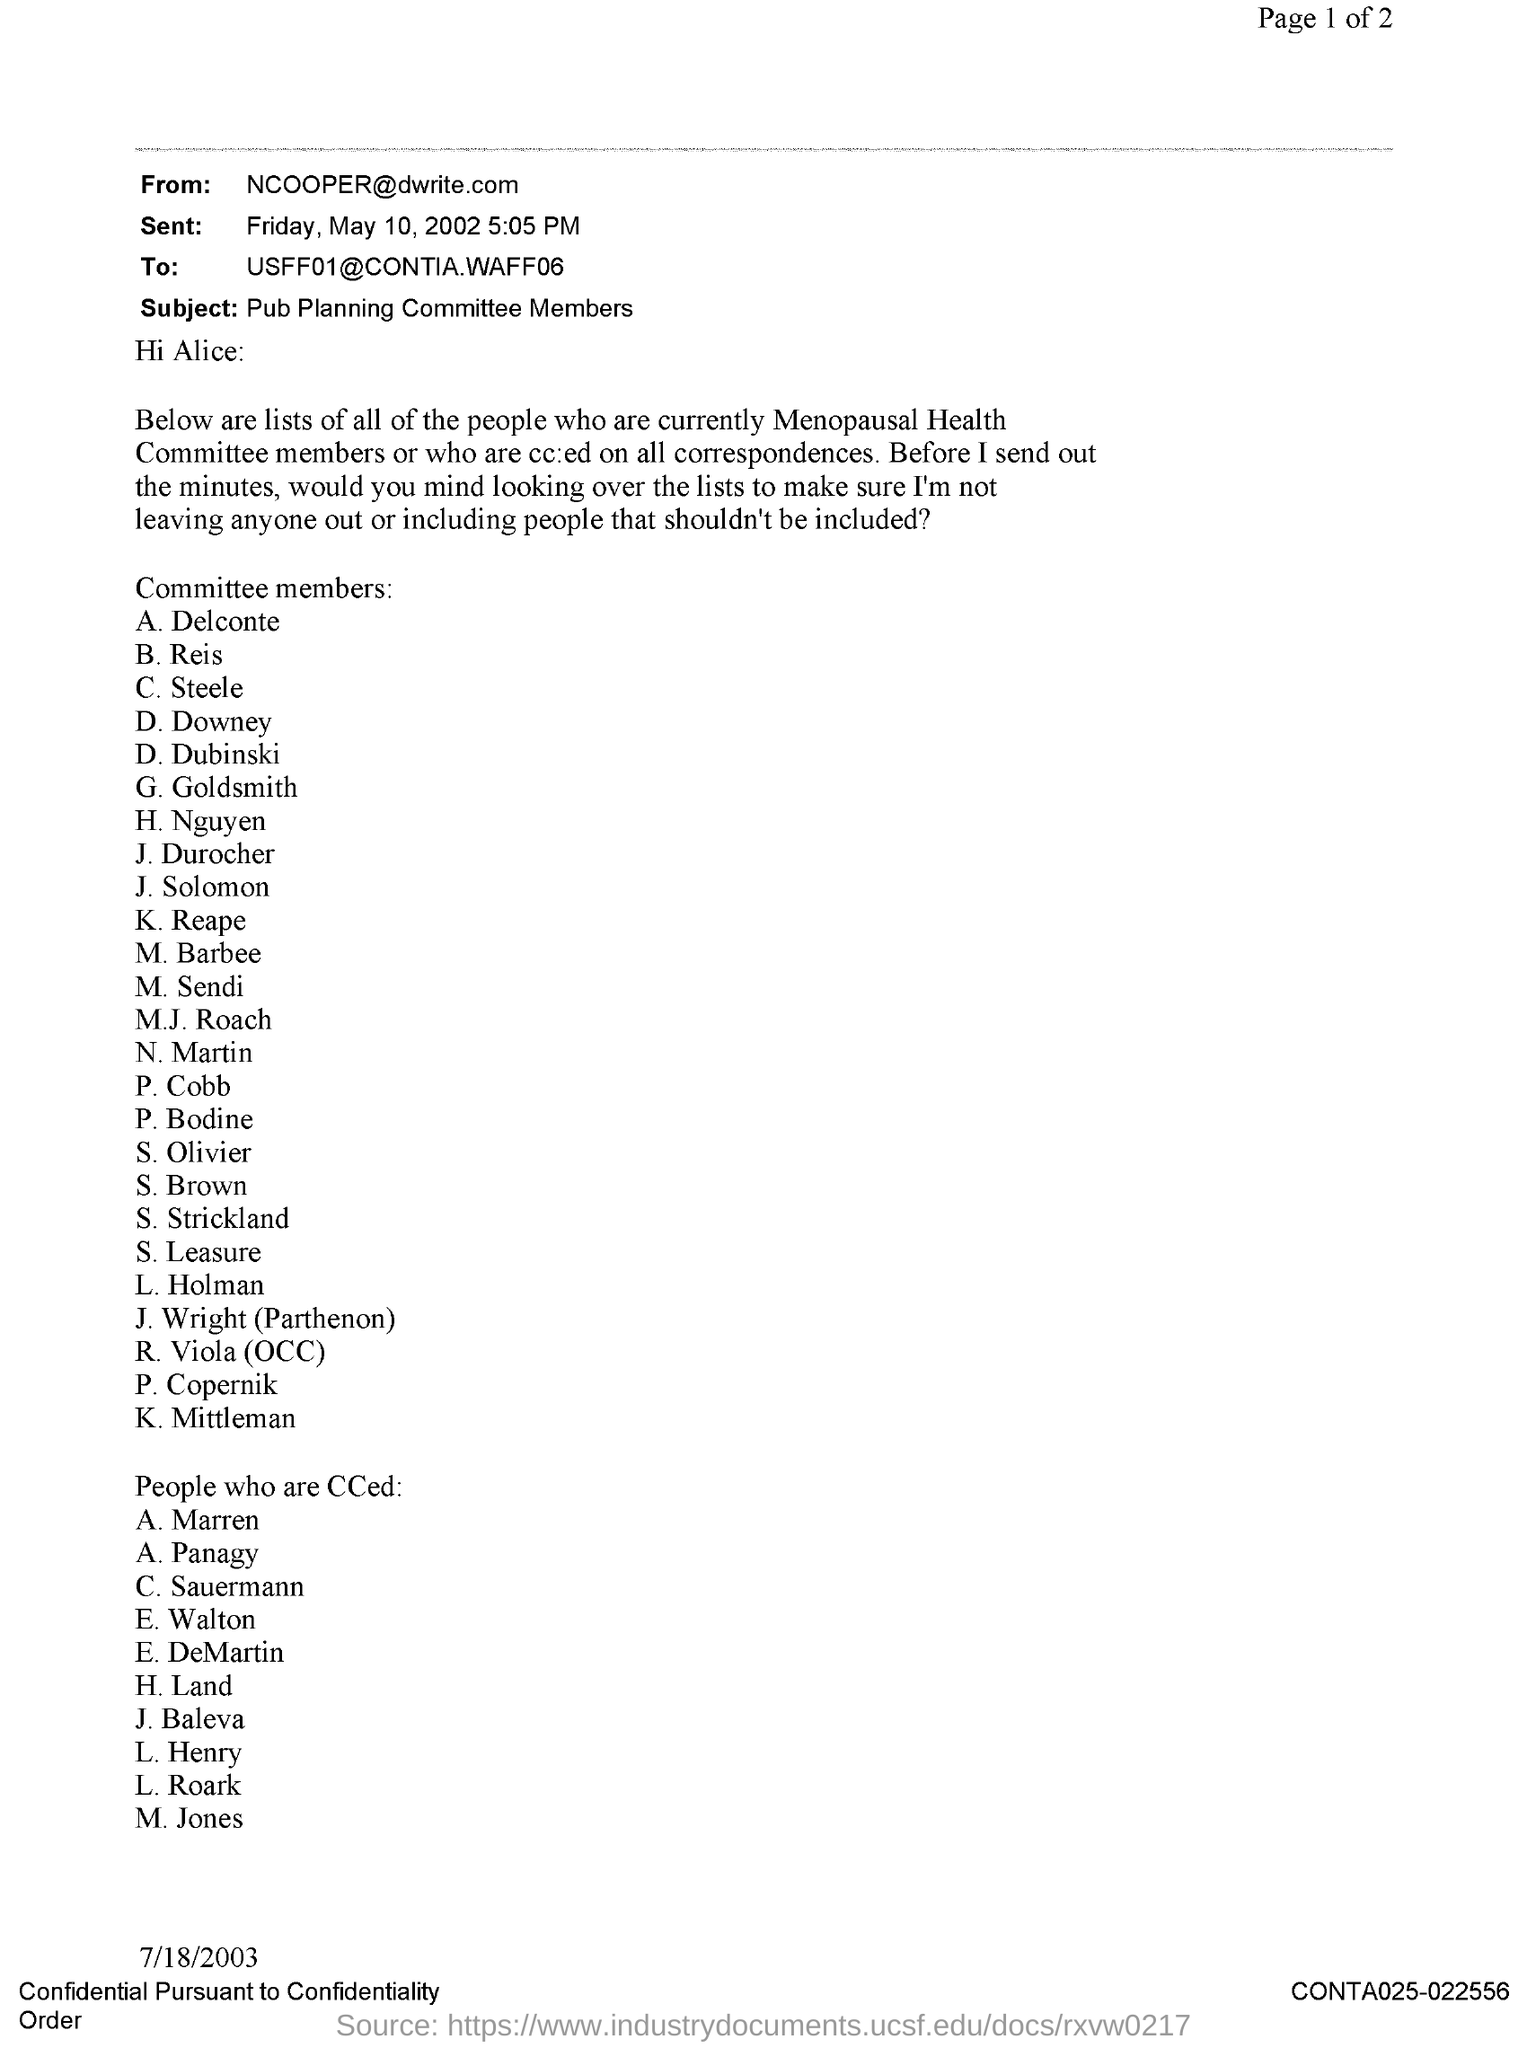Who is it from?
Offer a very short reply. NCOOPER@dwrite.com. When was it sent?
Offer a terse response. FRIDAY, MAY 10, 2002 5:05 PM. Who is it addressed to?
Your response must be concise. USFF01@CONTIA.WAFF06. What is the subject?
Ensure brevity in your answer.  Pub Planning committee members. What is the date on the document?
Provide a short and direct response. 7/18/2003. What is the Document Number?
Keep it short and to the point. CONTA025-022556. 